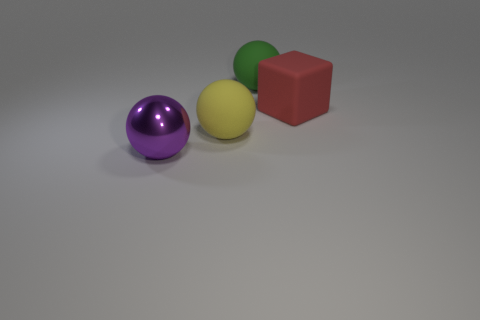Is the number of metallic things that are on the right side of the yellow rubber object less than the number of big blue matte objects?
Your answer should be very brief. No. Is the shape of the yellow matte thing the same as the green rubber thing?
Offer a terse response. Yes. Is there anything else that has the same shape as the red matte thing?
Your answer should be very brief. No. Are there any big purple matte cylinders?
Keep it short and to the point. No. There is a big purple object; does it have the same shape as the large matte thing behind the big red rubber thing?
Make the answer very short. Yes. The big sphere that is to the left of the big matte sphere in front of the big matte cube is made of what material?
Provide a short and direct response. Metal. The large block is what color?
Keep it short and to the point. Red. How many things are either big green matte balls on the right side of the purple thing or yellow matte objects?
Give a very brief answer. 2. There is a block that is the same material as the large green ball; what color is it?
Keep it short and to the point. Red. Are there any metallic spheres of the same size as the yellow matte ball?
Offer a terse response. Yes. 